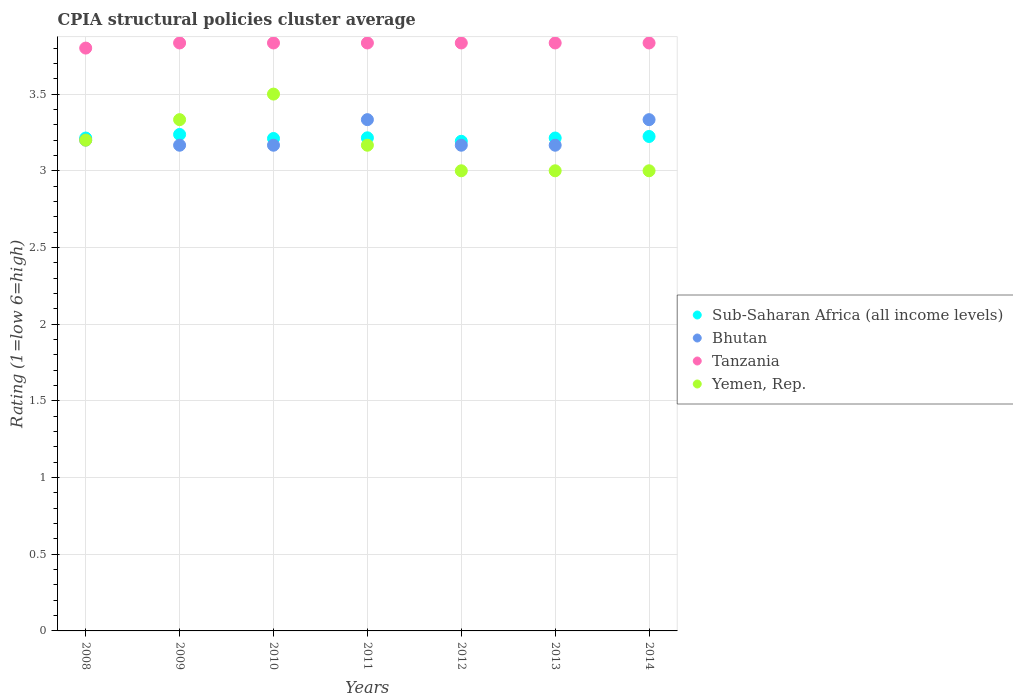What is the CPIA rating in Bhutan in 2010?
Offer a terse response. 3.17. Across all years, what is the maximum CPIA rating in Tanzania?
Your answer should be very brief. 3.83. In which year was the CPIA rating in Tanzania maximum?
Offer a very short reply. 2009. What is the total CPIA rating in Tanzania in the graph?
Give a very brief answer. 26.8. What is the difference between the CPIA rating in Yemen, Rep. in 2008 and that in 2013?
Your answer should be compact. 0.2. What is the difference between the CPIA rating in Yemen, Rep. in 2009 and the CPIA rating in Bhutan in 2012?
Make the answer very short. 0.17. What is the average CPIA rating in Bhutan per year?
Keep it short and to the point. 3.22. In the year 2014, what is the difference between the CPIA rating in Bhutan and CPIA rating in Yemen, Rep.?
Make the answer very short. 0.33. What is the ratio of the CPIA rating in Sub-Saharan Africa (all income levels) in 2012 to that in 2014?
Your answer should be very brief. 0.99. Is the difference between the CPIA rating in Bhutan in 2009 and 2011 greater than the difference between the CPIA rating in Yemen, Rep. in 2009 and 2011?
Offer a very short reply. No. What is the difference between the highest and the second highest CPIA rating in Yemen, Rep.?
Your response must be concise. 0.17. What is the difference between the highest and the lowest CPIA rating in Tanzania?
Make the answer very short. 0.03. Does the CPIA rating in Yemen, Rep. monotonically increase over the years?
Make the answer very short. No. Is the CPIA rating in Tanzania strictly greater than the CPIA rating in Yemen, Rep. over the years?
Offer a very short reply. Yes. Is the CPIA rating in Bhutan strictly less than the CPIA rating in Sub-Saharan Africa (all income levels) over the years?
Offer a terse response. No. How many years are there in the graph?
Offer a terse response. 7. Are the values on the major ticks of Y-axis written in scientific E-notation?
Give a very brief answer. No. Does the graph contain grids?
Provide a short and direct response. Yes. Where does the legend appear in the graph?
Ensure brevity in your answer.  Center right. How many legend labels are there?
Give a very brief answer. 4. What is the title of the graph?
Provide a short and direct response. CPIA structural policies cluster average. What is the label or title of the X-axis?
Make the answer very short. Years. What is the label or title of the Y-axis?
Your response must be concise. Rating (1=low 6=high). What is the Rating (1=low 6=high) of Sub-Saharan Africa (all income levels) in 2008?
Give a very brief answer. 3.21. What is the Rating (1=low 6=high) in Yemen, Rep. in 2008?
Your answer should be very brief. 3.2. What is the Rating (1=low 6=high) in Sub-Saharan Africa (all income levels) in 2009?
Give a very brief answer. 3.24. What is the Rating (1=low 6=high) of Bhutan in 2009?
Offer a terse response. 3.17. What is the Rating (1=low 6=high) of Tanzania in 2009?
Your response must be concise. 3.83. What is the Rating (1=low 6=high) of Yemen, Rep. in 2009?
Make the answer very short. 3.33. What is the Rating (1=low 6=high) of Sub-Saharan Africa (all income levels) in 2010?
Your answer should be very brief. 3.21. What is the Rating (1=low 6=high) in Bhutan in 2010?
Give a very brief answer. 3.17. What is the Rating (1=low 6=high) of Tanzania in 2010?
Make the answer very short. 3.83. What is the Rating (1=low 6=high) of Yemen, Rep. in 2010?
Offer a very short reply. 3.5. What is the Rating (1=low 6=high) in Sub-Saharan Africa (all income levels) in 2011?
Offer a very short reply. 3.21. What is the Rating (1=low 6=high) of Bhutan in 2011?
Your response must be concise. 3.33. What is the Rating (1=low 6=high) in Tanzania in 2011?
Your answer should be very brief. 3.83. What is the Rating (1=low 6=high) of Yemen, Rep. in 2011?
Make the answer very short. 3.17. What is the Rating (1=low 6=high) in Sub-Saharan Africa (all income levels) in 2012?
Make the answer very short. 3.19. What is the Rating (1=low 6=high) in Bhutan in 2012?
Provide a short and direct response. 3.17. What is the Rating (1=low 6=high) in Tanzania in 2012?
Offer a terse response. 3.83. What is the Rating (1=low 6=high) in Yemen, Rep. in 2012?
Offer a terse response. 3. What is the Rating (1=low 6=high) of Sub-Saharan Africa (all income levels) in 2013?
Offer a terse response. 3.21. What is the Rating (1=low 6=high) in Bhutan in 2013?
Provide a short and direct response. 3.17. What is the Rating (1=low 6=high) in Tanzania in 2013?
Your response must be concise. 3.83. What is the Rating (1=low 6=high) of Sub-Saharan Africa (all income levels) in 2014?
Offer a terse response. 3.22. What is the Rating (1=low 6=high) in Bhutan in 2014?
Make the answer very short. 3.33. What is the Rating (1=low 6=high) in Tanzania in 2014?
Offer a terse response. 3.83. What is the Rating (1=low 6=high) in Yemen, Rep. in 2014?
Your answer should be very brief. 3. Across all years, what is the maximum Rating (1=low 6=high) in Sub-Saharan Africa (all income levels)?
Offer a terse response. 3.24. Across all years, what is the maximum Rating (1=low 6=high) of Bhutan?
Your response must be concise. 3.33. Across all years, what is the maximum Rating (1=low 6=high) in Tanzania?
Provide a short and direct response. 3.83. Across all years, what is the maximum Rating (1=low 6=high) in Yemen, Rep.?
Offer a very short reply. 3.5. Across all years, what is the minimum Rating (1=low 6=high) of Sub-Saharan Africa (all income levels)?
Keep it short and to the point. 3.19. Across all years, what is the minimum Rating (1=low 6=high) of Bhutan?
Your response must be concise. 3.17. Across all years, what is the minimum Rating (1=low 6=high) in Tanzania?
Your answer should be very brief. 3.8. Across all years, what is the minimum Rating (1=low 6=high) in Yemen, Rep.?
Your answer should be compact. 3. What is the total Rating (1=low 6=high) of Sub-Saharan Africa (all income levels) in the graph?
Offer a very short reply. 22.51. What is the total Rating (1=low 6=high) of Bhutan in the graph?
Offer a very short reply. 22.53. What is the total Rating (1=low 6=high) of Tanzania in the graph?
Keep it short and to the point. 26.8. What is the difference between the Rating (1=low 6=high) in Sub-Saharan Africa (all income levels) in 2008 and that in 2009?
Your answer should be compact. -0.02. What is the difference between the Rating (1=low 6=high) in Tanzania in 2008 and that in 2009?
Provide a short and direct response. -0.03. What is the difference between the Rating (1=low 6=high) in Yemen, Rep. in 2008 and that in 2009?
Provide a succinct answer. -0.13. What is the difference between the Rating (1=low 6=high) in Sub-Saharan Africa (all income levels) in 2008 and that in 2010?
Offer a very short reply. 0. What is the difference between the Rating (1=low 6=high) of Bhutan in 2008 and that in 2010?
Your response must be concise. 0.03. What is the difference between the Rating (1=low 6=high) of Tanzania in 2008 and that in 2010?
Your response must be concise. -0.03. What is the difference between the Rating (1=low 6=high) of Yemen, Rep. in 2008 and that in 2010?
Your answer should be very brief. -0.3. What is the difference between the Rating (1=low 6=high) in Sub-Saharan Africa (all income levels) in 2008 and that in 2011?
Provide a succinct answer. -0. What is the difference between the Rating (1=low 6=high) of Bhutan in 2008 and that in 2011?
Your answer should be very brief. -0.13. What is the difference between the Rating (1=low 6=high) of Tanzania in 2008 and that in 2011?
Provide a succinct answer. -0.03. What is the difference between the Rating (1=low 6=high) of Yemen, Rep. in 2008 and that in 2011?
Provide a succinct answer. 0.03. What is the difference between the Rating (1=low 6=high) in Sub-Saharan Africa (all income levels) in 2008 and that in 2012?
Ensure brevity in your answer.  0.02. What is the difference between the Rating (1=low 6=high) in Tanzania in 2008 and that in 2012?
Your response must be concise. -0.03. What is the difference between the Rating (1=low 6=high) of Yemen, Rep. in 2008 and that in 2012?
Your answer should be very brief. 0.2. What is the difference between the Rating (1=low 6=high) of Sub-Saharan Africa (all income levels) in 2008 and that in 2013?
Give a very brief answer. -0. What is the difference between the Rating (1=low 6=high) in Bhutan in 2008 and that in 2013?
Ensure brevity in your answer.  0.03. What is the difference between the Rating (1=low 6=high) in Tanzania in 2008 and that in 2013?
Ensure brevity in your answer.  -0.03. What is the difference between the Rating (1=low 6=high) of Sub-Saharan Africa (all income levels) in 2008 and that in 2014?
Give a very brief answer. -0.01. What is the difference between the Rating (1=low 6=high) in Bhutan in 2008 and that in 2014?
Provide a short and direct response. -0.13. What is the difference between the Rating (1=low 6=high) of Tanzania in 2008 and that in 2014?
Make the answer very short. -0.03. What is the difference between the Rating (1=low 6=high) in Yemen, Rep. in 2008 and that in 2014?
Your answer should be compact. 0.2. What is the difference between the Rating (1=low 6=high) of Sub-Saharan Africa (all income levels) in 2009 and that in 2010?
Keep it short and to the point. 0.03. What is the difference between the Rating (1=low 6=high) in Bhutan in 2009 and that in 2010?
Your response must be concise. 0. What is the difference between the Rating (1=low 6=high) in Sub-Saharan Africa (all income levels) in 2009 and that in 2011?
Ensure brevity in your answer.  0.02. What is the difference between the Rating (1=low 6=high) in Yemen, Rep. in 2009 and that in 2011?
Your answer should be compact. 0.17. What is the difference between the Rating (1=low 6=high) in Sub-Saharan Africa (all income levels) in 2009 and that in 2012?
Your response must be concise. 0.04. What is the difference between the Rating (1=low 6=high) of Bhutan in 2009 and that in 2012?
Ensure brevity in your answer.  0. What is the difference between the Rating (1=low 6=high) in Tanzania in 2009 and that in 2012?
Keep it short and to the point. 0. What is the difference between the Rating (1=low 6=high) of Sub-Saharan Africa (all income levels) in 2009 and that in 2013?
Your response must be concise. 0.02. What is the difference between the Rating (1=low 6=high) of Bhutan in 2009 and that in 2013?
Give a very brief answer. 0. What is the difference between the Rating (1=low 6=high) in Sub-Saharan Africa (all income levels) in 2009 and that in 2014?
Give a very brief answer. 0.01. What is the difference between the Rating (1=low 6=high) of Tanzania in 2009 and that in 2014?
Provide a short and direct response. 0. What is the difference between the Rating (1=low 6=high) in Sub-Saharan Africa (all income levels) in 2010 and that in 2011?
Your answer should be compact. -0. What is the difference between the Rating (1=low 6=high) of Tanzania in 2010 and that in 2011?
Provide a succinct answer. 0. What is the difference between the Rating (1=low 6=high) of Yemen, Rep. in 2010 and that in 2011?
Your response must be concise. 0.33. What is the difference between the Rating (1=low 6=high) of Sub-Saharan Africa (all income levels) in 2010 and that in 2012?
Make the answer very short. 0.02. What is the difference between the Rating (1=low 6=high) in Tanzania in 2010 and that in 2012?
Give a very brief answer. 0. What is the difference between the Rating (1=low 6=high) of Sub-Saharan Africa (all income levels) in 2010 and that in 2013?
Offer a terse response. -0. What is the difference between the Rating (1=low 6=high) in Bhutan in 2010 and that in 2013?
Provide a succinct answer. 0. What is the difference between the Rating (1=low 6=high) of Tanzania in 2010 and that in 2013?
Make the answer very short. 0. What is the difference between the Rating (1=low 6=high) in Sub-Saharan Africa (all income levels) in 2010 and that in 2014?
Keep it short and to the point. -0.01. What is the difference between the Rating (1=low 6=high) in Bhutan in 2010 and that in 2014?
Offer a terse response. -0.17. What is the difference between the Rating (1=low 6=high) in Yemen, Rep. in 2010 and that in 2014?
Keep it short and to the point. 0.5. What is the difference between the Rating (1=low 6=high) of Sub-Saharan Africa (all income levels) in 2011 and that in 2012?
Provide a succinct answer. 0.02. What is the difference between the Rating (1=low 6=high) of Bhutan in 2011 and that in 2012?
Your answer should be very brief. 0.17. What is the difference between the Rating (1=low 6=high) of Yemen, Rep. in 2011 and that in 2012?
Your answer should be very brief. 0.17. What is the difference between the Rating (1=low 6=high) of Sub-Saharan Africa (all income levels) in 2011 and that in 2013?
Give a very brief answer. 0. What is the difference between the Rating (1=low 6=high) of Bhutan in 2011 and that in 2013?
Your answer should be very brief. 0.17. What is the difference between the Rating (1=low 6=high) in Sub-Saharan Africa (all income levels) in 2011 and that in 2014?
Provide a succinct answer. -0.01. What is the difference between the Rating (1=low 6=high) in Yemen, Rep. in 2011 and that in 2014?
Make the answer very short. 0.17. What is the difference between the Rating (1=low 6=high) of Sub-Saharan Africa (all income levels) in 2012 and that in 2013?
Ensure brevity in your answer.  -0.02. What is the difference between the Rating (1=low 6=high) in Sub-Saharan Africa (all income levels) in 2012 and that in 2014?
Your answer should be very brief. -0.03. What is the difference between the Rating (1=low 6=high) in Sub-Saharan Africa (all income levels) in 2013 and that in 2014?
Ensure brevity in your answer.  -0.01. What is the difference between the Rating (1=low 6=high) in Bhutan in 2013 and that in 2014?
Offer a terse response. -0.17. What is the difference between the Rating (1=low 6=high) in Yemen, Rep. in 2013 and that in 2014?
Make the answer very short. 0. What is the difference between the Rating (1=low 6=high) of Sub-Saharan Africa (all income levels) in 2008 and the Rating (1=low 6=high) of Bhutan in 2009?
Make the answer very short. 0.05. What is the difference between the Rating (1=low 6=high) of Sub-Saharan Africa (all income levels) in 2008 and the Rating (1=low 6=high) of Tanzania in 2009?
Ensure brevity in your answer.  -0.62. What is the difference between the Rating (1=low 6=high) of Sub-Saharan Africa (all income levels) in 2008 and the Rating (1=low 6=high) of Yemen, Rep. in 2009?
Offer a terse response. -0.12. What is the difference between the Rating (1=low 6=high) of Bhutan in 2008 and the Rating (1=low 6=high) of Tanzania in 2009?
Offer a very short reply. -0.63. What is the difference between the Rating (1=low 6=high) in Bhutan in 2008 and the Rating (1=low 6=high) in Yemen, Rep. in 2009?
Make the answer very short. -0.13. What is the difference between the Rating (1=low 6=high) of Tanzania in 2008 and the Rating (1=low 6=high) of Yemen, Rep. in 2009?
Offer a very short reply. 0.47. What is the difference between the Rating (1=low 6=high) in Sub-Saharan Africa (all income levels) in 2008 and the Rating (1=low 6=high) in Bhutan in 2010?
Your response must be concise. 0.05. What is the difference between the Rating (1=low 6=high) of Sub-Saharan Africa (all income levels) in 2008 and the Rating (1=low 6=high) of Tanzania in 2010?
Make the answer very short. -0.62. What is the difference between the Rating (1=low 6=high) of Sub-Saharan Africa (all income levels) in 2008 and the Rating (1=low 6=high) of Yemen, Rep. in 2010?
Ensure brevity in your answer.  -0.29. What is the difference between the Rating (1=low 6=high) of Bhutan in 2008 and the Rating (1=low 6=high) of Tanzania in 2010?
Provide a short and direct response. -0.63. What is the difference between the Rating (1=low 6=high) in Tanzania in 2008 and the Rating (1=low 6=high) in Yemen, Rep. in 2010?
Offer a terse response. 0.3. What is the difference between the Rating (1=low 6=high) of Sub-Saharan Africa (all income levels) in 2008 and the Rating (1=low 6=high) of Bhutan in 2011?
Ensure brevity in your answer.  -0.12. What is the difference between the Rating (1=low 6=high) in Sub-Saharan Africa (all income levels) in 2008 and the Rating (1=low 6=high) in Tanzania in 2011?
Keep it short and to the point. -0.62. What is the difference between the Rating (1=low 6=high) of Sub-Saharan Africa (all income levels) in 2008 and the Rating (1=low 6=high) of Yemen, Rep. in 2011?
Keep it short and to the point. 0.05. What is the difference between the Rating (1=low 6=high) of Bhutan in 2008 and the Rating (1=low 6=high) of Tanzania in 2011?
Give a very brief answer. -0.63. What is the difference between the Rating (1=low 6=high) of Tanzania in 2008 and the Rating (1=low 6=high) of Yemen, Rep. in 2011?
Your answer should be very brief. 0.63. What is the difference between the Rating (1=low 6=high) of Sub-Saharan Africa (all income levels) in 2008 and the Rating (1=low 6=high) of Bhutan in 2012?
Provide a succinct answer. 0.05. What is the difference between the Rating (1=low 6=high) of Sub-Saharan Africa (all income levels) in 2008 and the Rating (1=low 6=high) of Tanzania in 2012?
Ensure brevity in your answer.  -0.62. What is the difference between the Rating (1=low 6=high) in Sub-Saharan Africa (all income levels) in 2008 and the Rating (1=low 6=high) in Yemen, Rep. in 2012?
Offer a terse response. 0.21. What is the difference between the Rating (1=low 6=high) of Bhutan in 2008 and the Rating (1=low 6=high) of Tanzania in 2012?
Provide a short and direct response. -0.63. What is the difference between the Rating (1=low 6=high) in Tanzania in 2008 and the Rating (1=low 6=high) in Yemen, Rep. in 2012?
Offer a terse response. 0.8. What is the difference between the Rating (1=low 6=high) of Sub-Saharan Africa (all income levels) in 2008 and the Rating (1=low 6=high) of Bhutan in 2013?
Ensure brevity in your answer.  0.05. What is the difference between the Rating (1=low 6=high) in Sub-Saharan Africa (all income levels) in 2008 and the Rating (1=low 6=high) in Tanzania in 2013?
Give a very brief answer. -0.62. What is the difference between the Rating (1=low 6=high) in Sub-Saharan Africa (all income levels) in 2008 and the Rating (1=low 6=high) in Yemen, Rep. in 2013?
Your answer should be very brief. 0.21. What is the difference between the Rating (1=low 6=high) of Bhutan in 2008 and the Rating (1=low 6=high) of Tanzania in 2013?
Your answer should be very brief. -0.63. What is the difference between the Rating (1=low 6=high) in Bhutan in 2008 and the Rating (1=low 6=high) in Yemen, Rep. in 2013?
Offer a very short reply. 0.2. What is the difference between the Rating (1=low 6=high) in Sub-Saharan Africa (all income levels) in 2008 and the Rating (1=low 6=high) in Bhutan in 2014?
Offer a very short reply. -0.12. What is the difference between the Rating (1=low 6=high) of Sub-Saharan Africa (all income levels) in 2008 and the Rating (1=low 6=high) of Tanzania in 2014?
Keep it short and to the point. -0.62. What is the difference between the Rating (1=low 6=high) of Sub-Saharan Africa (all income levels) in 2008 and the Rating (1=low 6=high) of Yemen, Rep. in 2014?
Offer a terse response. 0.21. What is the difference between the Rating (1=low 6=high) in Bhutan in 2008 and the Rating (1=low 6=high) in Tanzania in 2014?
Provide a succinct answer. -0.63. What is the difference between the Rating (1=low 6=high) in Bhutan in 2008 and the Rating (1=low 6=high) in Yemen, Rep. in 2014?
Offer a very short reply. 0.2. What is the difference between the Rating (1=low 6=high) in Tanzania in 2008 and the Rating (1=low 6=high) in Yemen, Rep. in 2014?
Offer a very short reply. 0.8. What is the difference between the Rating (1=low 6=high) in Sub-Saharan Africa (all income levels) in 2009 and the Rating (1=low 6=high) in Bhutan in 2010?
Offer a very short reply. 0.07. What is the difference between the Rating (1=low 6=high) of Sub-Saharan Africa (all income levels) in 2009 and the Rating (1=low 6=high) of Tanzania in 2010?
Your response must be concise. -0.6. What is the difference between the Rating (1=low 6=high) in Sub-Saharan Africa (all income levels) in 2009 and the Rating (1=low 6=high) in Yemen, Rep. in 2010?
Provide a succinct answer. -0.26. What is the difference between the Rating (1=low 6=high) in Bhutan in 2009 and the Rating (1=low 6=high) in Tanzania in 2010?
Give a very brief answer. -0.67. What is the difference between the Rating (1=low 6=high) of Bhutan in 2009 and the Rating (1=low 6=high) of Yemen, Rep. in 2010?
Your answer should be compact. -0.33. What is the difference between the Rating (1=low 6=high) of Sub-Saharan Africa (all income levels) in 2009 and the Rating (1=low 6=high) of Bhutan in 2011?
Provide a short and direct response. -0.1. What is the difference between the Rating (1=low 6=high) of Sub-Saharan Africa (all income levels) in 2009 and the Rating (1=low 6=high) of Tanzania in 2011?
Make the answer very short. -0.6. What is the difference between the Rating (1=low 6=high) of Sub-Saharan Africa (all income levels) in 2009 and the Rating (1=low 6=high) of Yemen, Rep. in 2011?
Offer a terse response. 0.07. What is the difference between the Rating (1=low 6=high) of Tanzania in 2009 and the Rating (1=low 6=high) of Yemen, Rep. in 2011?
Provide a short and direct response. 0.67. What is the difference between the Rating (1=low 6=high) in Sub-Saharan Africa (all income levels) in 2009 and the Rating (1=low 6=high) in Bhutan in 2012?
Make the answer very short. 0.07. What is the difference between the Rating (1=low 6=high) of Sub-Saharan Africa (all income levels) in 2009 and the Rating (1=low 6=high) of Tanzania in 2012?
Your answer should be very brief. -0.6. What is the difference between the Rating (1=low 6=high) of Sub-Saharan Africa (all income levels) in 2009 and the Rating (1=low 6=high) of Yemen, Rep. in 2012?
Your answer should be very brief. 0.24. What is the difference between the Rating (1=low 6=high) in Bhutan in 2009 and the Rating (1=low 6=high) in Tanzania in 2012?
Offer a terse response. -0.67. What is the difference between the Rating (1=low 6=high) of Bhutan in 2009 and the Rating (1=low 6=high) of Yemen, Rep. in 2012?
Your response must be concise. 0.17. What is the difference between the Rating (1=low 6=high) in Tanzania in 2009 and the Rating (1=low 6=high) in Yemen, Rep. in 2012?
Make the answer very short. 0.83. What is the difference between the Rating (1=low 6=high) of Sub-Saharan Africa (all income levels) in 2009 and the Rating (1=low 6=high) of Bhutan in 2013?
Your response must be concise. 0.07. What is the difference between the Rating (1=low 6=high) of Sub-Saharan Africa (all income levels) in 2009 and the Rating (1=low 6=high) of Tanzania in 2013?
Ensure brevity in your answer.  -0.6. What is the difference between the Rating (1=low 6=high) of Sub-Saharan Africa (all income levels) in 2009 and the Rating (1=low 6=high) of Yemen, Rep. in 2013?
Offer a very short reply. 0.24. What is the difference between the Rating (1=low 6=high) in Bhutan in 2009 and the Rating (1=low 6=high) in Tanzania in 2013?
Your answer should be compact. -0.67. What is the difference between the Rating (1=low 6=high) of Bhutan in 2009 and the Rating (1=low 6=high) of Yemen, Rep. in 2013?
Make the answer very short. 0.17. What is the difference between the Rating (1=low 6=high) of Tanzania in 2009 and the Rating (1=low 6=high) of Yemen, Rep. in 2013?
Offer a very short reply. 0.83. What is the difference between the Rating (1=low 6=high) in Sub-Saharan Africa (all income levels) in 2009 and the Rating (1=low 6=high) in Bhutan in 2014?
Give a very brief answer. -0.1. What is the difference between the Rating (1=low 6=high) of Sub-Saharan Africa (all income levels) in 2009 and the Rating (1=low 6=high) of Tanzania in 2014?
Keep it short and to the point. -0.6. What is the difference between the Rating (1=low 6=high) in Sub-Saharan Africa (all income levels) in 2009 and the Rating (1=low 6=high) in Yemen, Rep. in 2014?
Ensure brevity in your answer.  0.24. What is the difference between the Rating (1=low 6=high) in Tanzania in 2009 and the Rating (1=low 6=high) in Yemen, Rep. in 2014?
Your answer should be compact. 0.83. What is the difference between the Rating (1=low 6=high) in Sub-Saharan Africa (all income levels) in 2010 and the Rating (1=low 6=high) in Bhutan in 2011?
Your answer should be very brief. -0.12. What is the difference between the Rating (1=low 6=high) of Sub-Saharan Africa (all income levels) in 2010 and the Rating (1=low 6=high) of Tanzania in 2011?
Offer a terse response. -0.62. What is the difference between the Rating (1=low 6=high) in Sub-Saharan Africa (all income levels) in 2010 and the Rating (1=low 6=high) in Yemen, Rep. in 2011?
Provide a short and direct response. 0.04. What is the difference between the Rating (1=low 6=high) of Bhutan in 2010 and the Rating (1=low 6=high) of Tanzania in 2011?
Your answer should be very brief. -0.67. What is the difference between the Rating (1=low 6=high) of Tanzania in 2010 and the Rating (1=low 6=high) of Yemen, Rep. in 2011?
Provide a short and direct response. 0.67. What is the difference between the Rating (1=low 6=high) in Sub-Saharan Africa (all income levels) in 2010 and the Rating (1=low 6=high) in Bhutan in 2012?
Provide a short and direct response. 0.04. What is the difference between the Rating (1=low 6=high) in Sub-Saharan Africa (all income levels) in 2010 and the Rating (1=low 6=high) in Tanzania in 2012?
Offer a terse response. -0.62. What is the difference between the Rating (1=low 6=high) of Sub-Saharan Africa (all income levels) in 2010 and the Rating (1=low 6=high) of Yemen, Rep. in 2012?
Your answer should be very brief. 0.21. What is the difference between the Rating (1=low 6=high) of Sub-Saharan Africa (all income levels) in 2010 and the Rating (1=low 6=high) of Bhutan in 2013?
Give a very brief answer. 0.04. What is the difference between the Rating (1=low 6=high) of Sub-Saharan Africa (all income levels) in 2010 and the Rating (1=low 6=high) of Tanzania in 2013?
Provide a succinct answer. -0.62. What is the difference between the Rating (1=low 6=high) of Sub-Saharan Africa (all income levels) in 2010 and the Rating (1=low 6=high) of Yemen, Rep. in 2013?
Provide a succinct answer. 0.21. What is the difference between the Rating (1=low 6=high) of Bhutan in 2010 and the Rating (1=low 6=high) of Tanzania in 2013?
Your answer should be compact. -0.67. What is the difference between the Rating (1=low 6=high) of Tanzania in 2010 and the Rating (1=low 6=high) of Yemen, Rep. in 2013?
Keep it short and to the point. 0.83. What is the difference between the Rating (1=low 6=high) of Sub-Saharan Africa (all income levels) in 2010 and the Rating (1=low 6=high) of Bhutan in 2014?
Your answer should be compact. -0.12. What is the difference between the Rating (1=low 6=high) of Sub-Saharan Africa (all income levels) in 2010 and the Rating (1=low 6=high) of Tanzania in 2014?
Your answer should be very brief. -0.62. What is the difference between the Rating (1=low 6=high) in Sub-Saharan Africa (all income levels) in 2010 and the Rating (1=low 6=high) in Yemen, Rep. in 2014?
Make the answer very short. 0.21. What is the difference between the Rating (1=low 6=high) of Sub-Saharan Africa (all income levels) in 2011 and the Rating (1=low 6=high) of Bhutan in 2012?
Keep it short and to the point. 0.05. What is the difference between the Rating (1=low 6=high) of Sub-Saharan Africa (all income levels) in 2011 and the Rating (1=low 6=high) of Tanzania in 2012?
Provide a short and direct response. -0.62. What is the difference between the Rating (1=low 6=high) of Sub-Saharan Africa (all income levels) in 2011 and the Rating (1=low 6=high) of Yemen, Rep. in 2012?
Provide a short and direct response. 0.21. What is the difference between the Rating (1=low 6=high) in Bhutan in 2011 and the Rating (1=low 6=high) in Tanzania in 2012?
Your response must be concise. -0.5. What is the difference between the Rating (1=low 6=high) of Sub-Saharan Africa (all income levels) in 2011 and the Rating (1=low 6=high) of Bhutan in 2013?
Offer a terse response. 0.05. What is the difference between the Rating (1=low 6=high) of Sub-Saharan Africa (all income levels) in 2011 and the Rating (1=low 6=high) of Tanzania in 2013?
Your response must be concise. -0.62. What is the difference between the Rating (1=low 6=high) in Sub-Saharan Africa (all income levels) in 2011 and the Rating (1=low 6=high) in Yemen, Rep. in 2013?
Your response must be concise. 0.21. What is the difference between the Rating (1=low 6=high) in Bhutan in 2011 and the Rating (1=low 6=high) in Tanzania in 2013?
Give a very brief answer. -0.5. What is the difference between the Rating (1=low 6=high) in Bhutan in 2011 and the Rating (1=low 6=high) in Yemen, Rep. in 2013?
Offer a very short reply. 0.33. What is the difference between the Rating (1=low 6=high) of Tanzania in 2011 and the Rating (1=low 6=high) of Yemen, Rep. in 2013?
Make the answer very short. 0.83. What is the difference between the Rating (1=low 6=high) in Sub-Saharan Africa (all income levels) in 2011 and the Rating (1=low 6=high) in Bhutan in 2014?
Offer a terse response. -0.12. What is the difference between the Rating (1=low 6=high) in Sub-Saharan Africa (all income levels) in 2011 and the Rating (1=low 6=high) in Tanzania in 2014?
Give a very brief answer. -0.62. What is the difference between the Rating (1=low 6=high) of Sub-Saharan Africa (all income levels) in 2011 and the Rating (1=low 6=high) of Yemen, Rep. in 2014?
Make the answer very short. 0.21. What is the difference between the Rating (1=low 6=high) of Tanzania in 2011 and the Rating (1=low 6=high) of Yemen, Rep. in 2014?
Offer a very short reply. 0.83. What is the difference between the Rating (1=low 6=high) of Sub-Saharan Africa (all income levels) in 2012 and the Rating (1=low 6=high) of Bhutan in 2013?
Provide a short and direct response. 0.03. What is the difference between the Rating (1=low 6=high) in Sub-Saharan Africa (all income levels) in 2012 and the Rating (1=low 6=high) in Tanzania in 2013?
Your answer should be compact. -0.64. What is the difference between the Rating (1=low 6=high) in Sub-Saharan Africa (all income levels) in 2012 and the Rating (1=low 6=high) in Yemen, Rep. in 2013?
Make the answer very short. 0.19. What is the difference between the Rating (1=low 6=high) of Bhutan in 2012 and the Rating (1=low 6=high) of Tanzania in 2013?
Your answer should be compact. -0.67. What is the difference between the Rating (1=low 6=high) in Bhutan in 2012 and the Rating (1=low 6=high) in Yemen, Rep. in 2013?
Offer a very short reply. 0.17. What is the difference between the Rating (1=low 6=high) of Sub-Saharan Africa (all income levels) in 2012 and the Rating (1=low 6=high) of Bhutan in 2014?
Offer a terse response. -0.14. What is the difference between the Rating (1=low 6=high) in Sub-Saharan Africa (all income levels) in 2012 and the Rating (1=low 6=high) in Tanzania in 2014?
Keep it short and to the point. -0.64. What is the difference between the Rating (1=low 6=high) of Sub-Saharan Africa (all income levels) in 2012 and the Rating (1=low 6=high) of Yemen, Rep. in 2014?
Keep it short and to the point. 0.19. What is the difference between the Rating (1=low 6=high) in Bhutan in 2012 and the Rating (1=low 6=high) in Tanzania in 2014?
Offer a very short reply. -0.67. What is the difference between the Rating (1=low 6=high) of Bhutan in 2012 and the Rating (1=low 6=high) of Yemen, Rep. in 2014?
Provide a short and direct response. 0.17. What is the difference between the Rating (1=low 6=high) in Tanzania in 2012 and the Rating (1=low 6=high) in Yemen, Rep. in 2014?
Provide a succinct answer. 0.83. What is the difference between the Rating (1=low 6=high) in Sub-Saharan Africa (all income levels) in 2013 and the Rating (1=low 6=high) in Bhutan in 2014?
Offer a terse response. -0.12. What is the difference between the Rating (1=low 6=high) of Sub-Saharan Africa (all income levels) in 2013 and the Rating (1=low 6=high) of Tanzania in 2014?
Your answer should be very brief. -0.62. What is the difference between the Rating (1=low 6=high) of Sub-Saharan Africa (all income levels) in 2013 and the Rating (1=low 6=high) of Yemen, Rep. in 2014?
Make the answer very short. 0.21. What is the difference between the Rating (1=low 6=high) of Tanzania in 2013 and the Rating (1=low 6=high) of Yemen, Rep. in 2014?
Give a very brief answer. 0.83. What is the average Rating (1=low 6=high) in Sub-Saharan Africa (all income levels) per year?
Make the answer very short. 3.22. What is the average Rating (1=low 6=high) in Bhutan per year?
Give a very brief answer. 3.22. What is the average Rating (1=low 6=high) in Tanzania per year?
Give a very brief answer. 3.83. What is the average Rating (1=low 6=high) in Yemen, Rep. per year?
Give a very brief answer. 3.17. In the year 2008, what is the difference between the Rating (1=low 6=high) of Sub-Saharan Africa (all income levels) and Rating (1=low 6=high) of Bhutan?
Provide a short and direct response. 0.01. In the year 2008, what is the difference between the Rating (1=low 6=high) in Sub-Saharan Africa (all income levels) and Rating (1=low 6=high) in Tanzania?
Provide a short and direct response. -0.59. In the year 2008, what is the difference between the Rating (1=low 6=high) in Sub-Saharan Africa (all income levels) and Rating (1=low 6=high) in Yemen, Rep.?
Provide a short and direct response. 0.01. In the year 2008, what is the difference between the Rating (1=low 6=high) in Tanzania and Rating (1=low 6=high) in Yemen, Rep.?
Offer a terse response. 0.6. In the year 2009, what is the difference between the Rating (1=low 6=high) of Sub-Saharan Africa (all income levels) and Rating (1=low 6=high) of Bhutan?
Ensure brevity in your answer.  0.07. In the year 2009, what is the difference between the Rating (1=low 6=high) in Sub-Saharan Africa (all income levels) and Rating (1=low 6=high) in Tanzania?
Provide a succinct answer. -0.6. In the year 2009, what is the difference between the Rating (1=low 6=high) of Sub-Saharan Africa (all income levels) and Rating (1=low 6=high) of Yemen, Rep.?
Your answer should be compact. -0.1. In the year 2009, what is the difference between the Rating (1=low 6=high) of Bhutan and Rating (1=low 6=high) of Tanzania?
Offer a terse response. -0.67. In the year 2010, what is the difference between the Rating (1=low 6=high) in Sub-Saharan Africa (all income levels) and Rating (1=low 6=high) in Bhutan?
Your answer should be compact. 0.04. In the year 2010, what is the difference between the Rating (1=low 6=high) of Sub-Saharan Africa (all income levels) and Rating (1=low 6=high) of Tanzania?
Provide a short and direct response. -0.62. In the year 2010, what is the difference between the Rating (1=low 6=high) of Sub-Saharan Africa (all income levels) and Rating (1=low 6=high) of Yemen, Rep.?
Keep it short and to the point. -0.29. In the year 2010, what is the difference between the Rating (1=low 6=high) of Bhutan and Rating (1=low 6=high) of Tanzania?
Keep it short and to the point. -0.67. In the year 2010, what is the difference between the Rating (1=low 6=high) of Bhutan and Rating (1=low 6=high) of Yemen, Rep.?
Make the answer very short. -0.33. In the year 2011, what is the difference between the Rating (1=low 6=high) of Sub-Saharan Africa (all income levels) and Rating (1=low 6=high) of Bhutan?
Offer a terse response. -0.12. In the year 2011, what is the difference between the Rating (1=low 6=high) of Sub-Saharan Africa (all income levels) and Rating (1=low 6=high) of Tanzania?
Your response must be concise. -0.62. In the year 2011, what is the difference between the Rating (1=low 6=high) of Sub-Saharan Africa (all income levels) and Rating (1=low 6=high) of Yemen, Rep.?
Your answer should be compact. 0.05. In the year 2012, what is the difference between the Rating (1=low 6=high) of Sub-Saharan Africa (all income levels) and Rating (1=low 6=high) of Bhutan?
Keep it short and to the point. 0.03. In the year 2012, what is the difference between the Rating (1=low 6=high) in Sub-Saharan Africa (all income levels) and Rating (1=low 6=high) in Tanzania?
Give a very brief answer. -0.64. In the year 2012, what is the difference between the Rating (1=low 6=high) in Sub-Saharan Africa (all income levels) and Rating (1=low 6=high) in Yemen, Rep.?
Offer a very short reply. 0.19. In the year 2013, what is the difference between the Rating (1=low 6=high) in Sub-Saharan Africa (all income levels) and Rating (1=low 6=high) in Bhutan?
Your answer should be compact. 0.05. In the year 2013, what is the difference between the Rating (1=low 6=high) of Sub-Saharan Africa (all income levels) and Rating (1=low 6=high) of Tanzania?
Offer a terse response. -0.62. In the year 2013, what is the difference between the Rating (1=low 6=high) of Sub-Saharan Africa (all income levels) and Rating (1=low 6=high) of Yemen, Rep.?
Make the answer very short. 0.21. In the year 2014, what is the difference between the Rating (1=low 6=high) in Sub-Saharan Africa (all income levels) and Rating (1=low 6=high) in Bhutan?
Provide a succinct answer. -0.11. In the year 2014, what is the difference between the Rating (1=low 6=high) in Sub-Saharan Africa (all income levels) and Rating (1=low 6=high) in Tanzania?
Provide a succinct answer. -0.61. In the year 2014, what is the difference between the Rating (1=low 6=high) in Sub-Saharan Africa (all income levels) and Rating (1=low 6=high) in Yemen, Rep.?
Provide a succinct answer. 0.22. In the year 2014, what is the difference between the Rating (1=low 6=high) in Bhutan and Rating (1=low 6=high) in Tanzania?
Give a very brief answer. -0.5. In the year 2014, what is the difference between the Rating (1=low 6=high) of Bhutan and Rating (1=low 6=high) of Yemen, Rep.?
Make the answer very short. 0.33. What is the ratio of the Rating (1=low 6=high) in Sub-Saharan Africa (all income levels) in 2008 to that in 2009?
Offer a very short reply. 0.99. What is the ratio of the Rating (1=low 6=high) of Bhutan in 2008 to that in 2009?
Give a very brief answer. 1.01. What is the ratio of the Rating (1=low 6=high) in Sub-Saharan Africa (all income levels) in 2008 to that in 2010?
Your response must be concise. 1. What is the ratio of the Rating (1=low 6=high) in Bhutan in 2008 to that in 2010?
Your answer should be very brief. 1.01. What is the ratio of the Rating (1=low 6=high) in Yemen, Rep. in 2008 to that in 2010?
Your answer should be compact. 0.91. What is the ratio of the Rating (1=low 6=high) of Yemen, Rep. in 2008 to that in 2011?
Ensure brevity in your answer.  1.01. What is the ratio of the Rating (1=low 6=high) of Sub-Saharan Africa (all income levels) in 2008 to that in 2012?
Offer a very short reply. 1.01. What is the ratio of the Rating (1=low 6=high) in Bhutan in 2008 to that in 2012?
Offer a terse response. 1.01. What is the ratio of the Rating (1=low 6=high) in Yemen, Rep. in 2008 to that in 2012?
Your answer should be very brief. 1.07. What is the ratio of the Rating (1=low 6=high) in Sub-Saharan Africa (all income levels) in 2008 to that in 2013?
Provide a succinct answer. 1. What is the ratio of the Rating (1=low 6=high) of Bhutan in 2008 to that in 2013?
Your response must be concise. 1.01. What is the ratio of the Rating (1=low 6=high) in Yemen, Rep. in 2008 to that in 2013?
Provide a succinct answer. 1.07. What is the ratio of the Rating (1=low 6=high) in Sub-Saharan Africa (all income levels) in 2008 to that in 2014?
Provide a succinct answer. 1. What is the ratio of the Rating (1=low 6=high) in Bhutan in 2008 to that in 2014?
Give a very brief answer. 0.96. What is the ratio of the Rating (1=low 6=high) in Tanzania in 2008 to that in 2014?
Provide a short and direct response. 0.99. What is the ratio of the Rating (1=low 6=high) in Yemen, Rep. in 2008 to that in 2014?
Offer a very short reply. 1.07. What is the ratio of the Rating (1=low 6=high) of Sub-Saharan Africa (all income levels) in 2009 to that in 2010?
Ensure brevity in your answer.  1.01. What is the ratio of the Rating (1=low 6=high) in Sub-Saharan Africa (all income levels) in 2009 to that in 2011?
Give a very brief answer. 1.01. What is the ratio of the Rating (1=low 6=high) of Bhutan in 2009 to that in 2011?
Your answer should be compact. 0.95. What is the ratio of the Rating (1=low 6=high) in Tanzania in 2009 to that in 2011?
Offer a very short reply. 1. What is the ratio of the Rating (1=low 6=high) in Yemen, Rep. in 2009 to that in 2011?
Offer a terse response. 1.05. What is the ratio of the Rating (1=low 6=high) of Bhutan in 2009 to that in 2012?
Keep it short and to the point. 1. What is the ratio of the Rating (1=low 6=high) of Tanzania in 2009 to that in 2012?
Your response must be concise. 1. What is the ratio of the Rating (1=low 6=high) of Yemen, Rep. in 2009 to that in 2012?
Provide a succinct answer. 1.11. What is the ratio of the Rating (1=low 6=high) in Bhutan in 2009 to that in 2013?
Give a very brief answer. 1. What is the ratio of the Rating (1=low 6=high) of Yemen, Rep. in 2009 to that in 2013?
Provide a short and direct response. 1.11. What is the ratio of the Rating (1=low 6=high) of Bhutan in 2009 to that in 2014?
Your response must be concise. 0.95. What is the ratio of the Rating (1=low 6=high) of Tanzania in 2009 to that in 2014?
Your answer should be compact. 1. What is the ratio of the Rating (1=low 6=high) in Yemen, Rep. in 2009 to that in 2014?
Offer a very short reply. 1.11. What is the ratio of the Rating (1=low 6=high) of Sub-Saharan Africa (all income levels) in 2010 to that in 2011?
Your answer should be compact. 1. What is the ratio of the Rating (1=low 6=high) of Bhutan in 2010 to that in 2011?
Keep it short and to the point. 0.95. What is the ratio of the Rating (1=low 6=high) of Yemen, Rep. in 2010 to that in 2011?
Provide a short and direct response. 1.11. What is the ratio of the Rating (1=low 6=high) in Sub-Saharan Africa (all income levels) in 2010 to that in 2012?
Provide a short and direct response. 1.01. What is the ratio of the Rating (1=low 6=high) of Bhutan in 2010 to that in 2012?
Offer a terse response. 1. What is the ratio of the Rating (1=low 6=high) in Tanzania in 2010 to that in 2012?
Keep it short and to the point. 1. What is the ratio of the Rating (1=low 6=high) in Yemen, Rep. in 2010 to that in 2012?
Provide a succinct answer. 1.17. What is the ratio of the Rating (1=low 6=high) of Bhutan in 2010 to that in 2014?
Offer a terse response. 0.95. What is the ratio of the Rating (1=low 6=high) of Yemen, Rep. in 2010 to that in 2014?
Your response must be concise. 1.17. What is the ratio of the Rating (1=low 6=high) in Sub-Saharan Africa (all income levels) in 2011 to that in 2012?
Offer a terse response. 1.01. What is the ratio of the Rating (1=low 6=high) of Bhutan in 2011 to that in 2012?
Give a very brief answer. 1.05. What is the ratio of the Rating (1=low 6=high) of Tanzania in 2011 to that in 2012?
Your response must be concise. 1. What is the ratio of the Rating (1=low 6=high) in Yemen, Rep. in 2011 to that in 2012?
Make the answer very short. 1.06. What is the ratio of the Rating (1=low 6=high) of Sub-Saharan Africa (all income levels) in 2011 to that in 2013?
Make the answer very short. 1. What is the ratio of the Rating (1=low 6=high) in Bhutan in 2011 to that in 2013?
Give a very brief answer. 1.05. What is the ratio of the Rating (1=low 6=high) of Tanzania in 2011 to that in 2013?
Provide a short and direct response. 1. What is the ratio of the Rating (1=low 6=high) of Yemen, Rep. in 2011 to that in 2013?
Your answer should be very brief. 1.06. What is the ratio of the Rating (1=low 6=high) of Tanzania in 2011 to that in 2014?
Your answer should be compact. 1. What is the ratio of the Rating (1=low 6=high) in Yemen, Rep. in 2011 to that in 2014?
Offer a terse response. 1.06. What is the ratio of the Rating (1=low 6=high) of Sub-Saharan Africa (all income levels) in 2012 to that in 2014?
Provide a short and direct response. 0.99. What is the ratio of the Rating (1=low 6=high) in Bhutan in 2012 to that in 2014?
Provide a succinct answer. 0.95. What is the ratio of the Rating (1=low 6=high) in Yemen, Rep. in 2012 to that in 2014?
Provide a short and direct response. 1. What is the ratio of the Rating (1=low 6=high) of Bhutan in 2013 to that in 2014?
Provide a short and direct response. 0.95. What is the difference between the highest and the second highest Rating (1=low 6=high) of Sub-Saharan Africa (all income levels)?
Offer a very short reply. 0.01. What is the difference between the highest and the second highest Rating (1=low 6=high) of Yemen, Rep.?
Ensure brevity in your answer.  0.17. What is the difference between the highest and the lowest Rating (1=low 6=high) in Sub-Saharan Africa (all income levels)?
Keep it short and to the point. 0.04. What is the difference between the highest and the lowest Rating (1=low 6=high) of Yemen, Rep.?
Your answer should be compact. 0.5. 